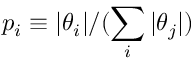<formula> <loc_0><loc_0><loc_500><loc_500>p _ { i } \equiv | \theta _ { i } | / ( \sum _ { i } | \theta _ { j } | )</formula> 